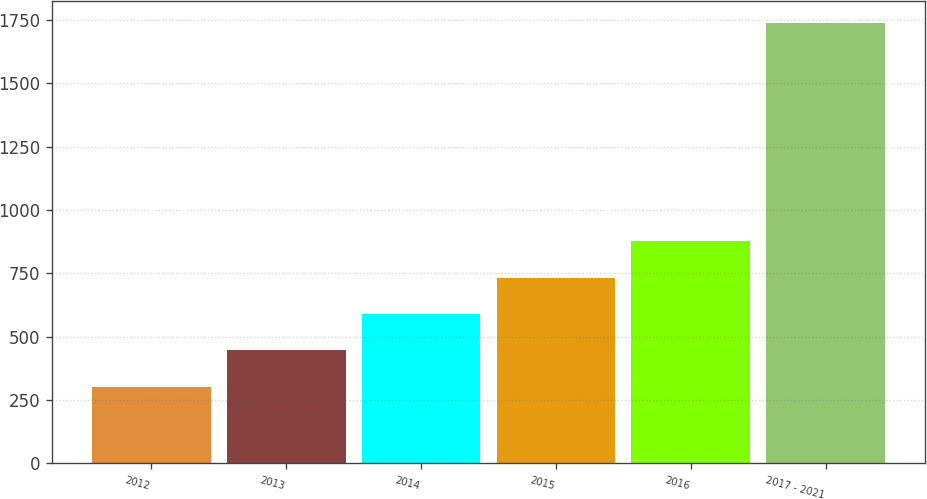Convert chart. <chart><loc_0><loc_0><loc_500><loc_500><bar_chart><fcel>2012<fcel>2013<fcel>2014<fcel>2015<fcel>2016<fcel>2017 - 2021<nl><fcel>302<fcel>445.6<fcel>589.2<fcel>732.8<fcel>876.4<fcel>1738<nl></chart> 